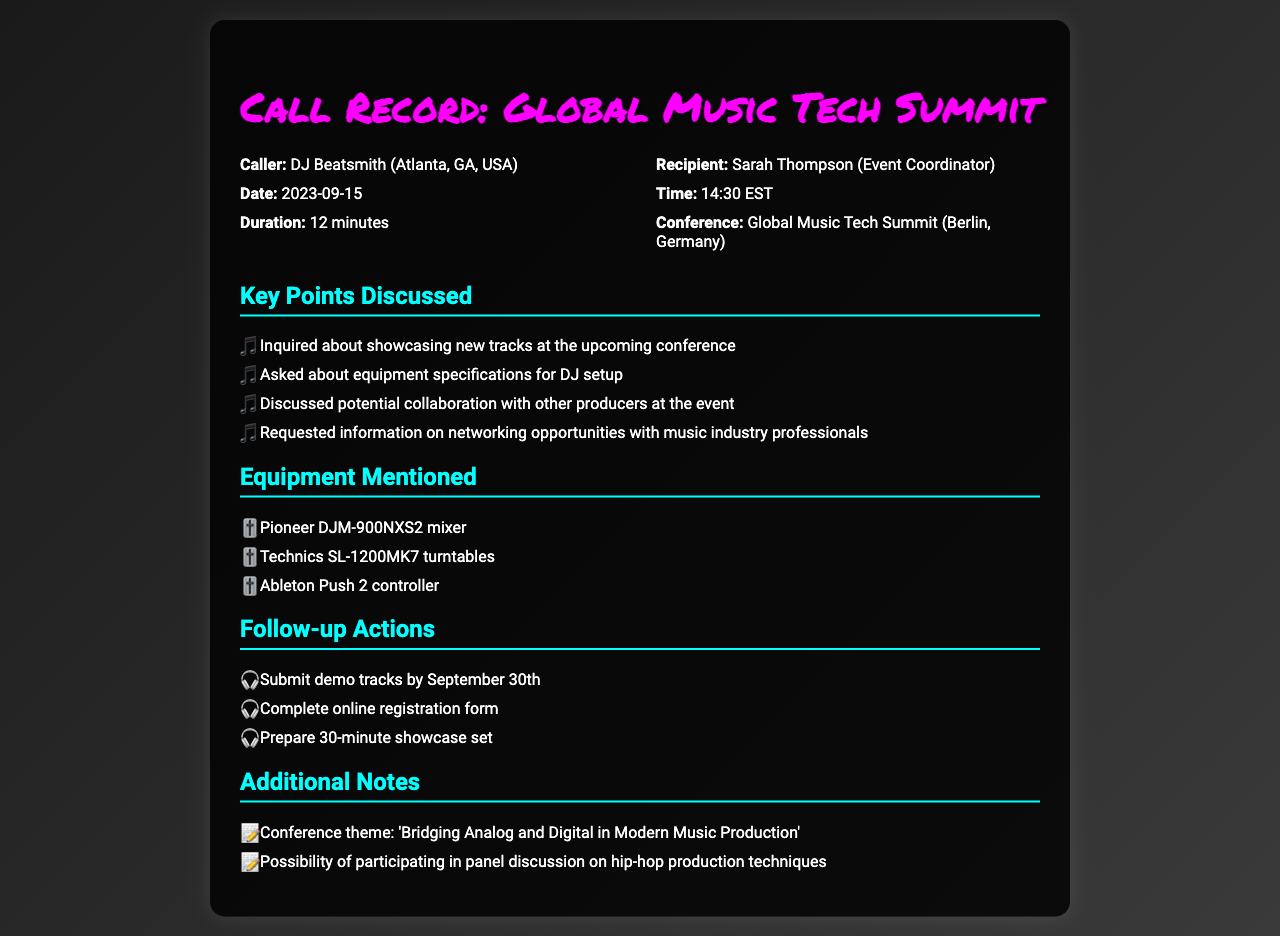what is the name of the caller? The name of the caller is mentioned at the beginning of the call record, which is DJ Beatsmith.
Answer: DJ Beatsmith who is the recipient of the call? The recipient of the call is specified in the call record as Sarah Thompson.
Answer: Sarah Thompson when was the call made? The date of the call is listed in the call record, which is September 15, 2023.
Answer: 2023-09-15 what is the duration of the call? The duration of the call is mentioned and recorded as 12 minutes.
Answer: 12 minutes what equipment mixer is mentioned? The equipment section lists the Pioneer DJM-900NXS2 mixer specifically.
Answer: Pioneer DJM-900NXS2 mixer what is the main theme of the conference? The theme of the conference is stated in the additional notes section as 'Bridging Analog and Digital in Modern Music Production'.
Answer: Bridging Analog and Digital in Modern Music Production how many follow-up actions are there? The follow-up actions section contains three specific actions to be completed, as noted in the document.
Answer: 3 what is the location of the conference? The call record mentions that the conference will take place in Berlin, Germany.
Answer: Berlin, Germany what is requested to be submitted by September 30th? The follow-up actions indicate that demo tracks need to be submitted by that date.
Answer: demo tracks 